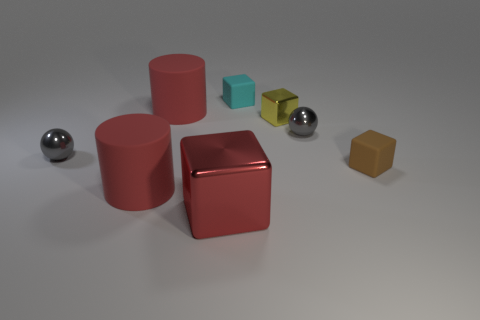Add 1 large blue cylinders. How many objects exist? 9 Subtract all brown matte blocks. How many blocks are left? 3 Subtract 4 blocks. How many blocks are left? 0 Subtract all tiny green rubber cylinders. Subtract all matte objects. How many objects are left? 4 Add 8 cyan things. How many cyan things are left? 9 Add 4 tiny rubber things. How many tiny rubber things exist? 6 Subtract all cyan cubes. How many cubes are left? 3 Subtract 0 green balls. How many objects are left? 8 Subtract all cylinders. How many objects are left? 6 Subtract all purple balls. Subtract all blue cubes. How many balls are left? 2 